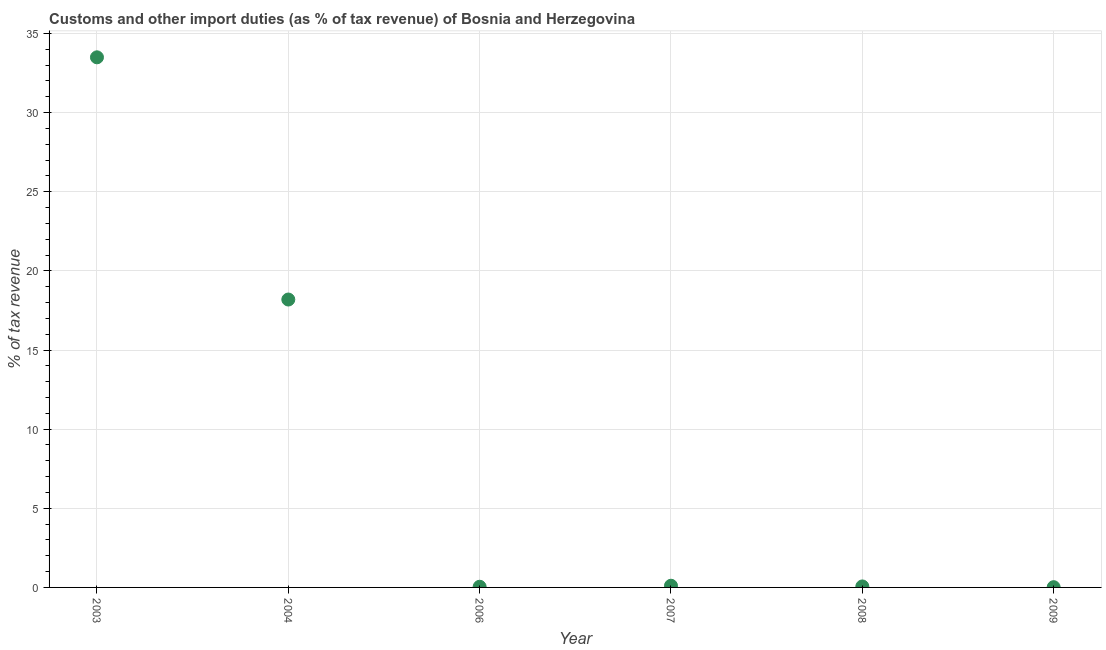What is the customs and other import duties in 2009?
Offer a very short reply. 0.02. Across all years, what is the maximum customs and other import duties?
Ensure brevity in your answer.  33.5. Across all years, what is the minimum customs and other import duties?
Offer a terse response. 0.02. In which year was the customs and other import duties maximum?
Ensure brevity in your answer.  2003. In which year was the customs and other import duties minimum?
Your answer should be very brief. 2009. What is the sum of the customs and other import duties?
Offer a terse response. 51.92. What is the difference between the customs and other import duties in 2003 and 2009?
Offer a very short reply. 33.48. What is the average customs and other import duties per year?
Offer a very short reply. 8.65. What is the median customs and other import duties?
Make the answer very short. 0.08. Do a majority of the years between 2006 and 2008 (inclusive) have customs and other import duties greater than 32 %?
Offer a terse response. No. What is the ratio of the customs and other import duties in 2003 to that in 2006?
Provide a succinct answer. 785.11. Is the customs and other import duties in 2004 less than that in 2006?
Your response must be concise. No. What is the difference between the highest and the second highest customs and other import duties?
Ensure brevity in your answer.  15.3. Is the sum of the customs and other import duties in 2008 and 2009 greater than the maximum customs and other import duties across all years?
Make the answer very short. No. What is the difference between the highest and the lowest customs and other import duties?
Offer a terse response. 33.48. Does the customs and other import duties monotonically increase over the years?
Your answer should be compact. No. How many dotlines are there?
Provide a short and direct response. 1. Are the values on the major ticks of Y-axis written in scientific E-notation?
Provide a short and direct response. No. What is the title of the graph?
Offer a very short reply. Customs and other import duties (as % of tax revenue) of Bosnia and Herzegovina. What is the label or title of the X-axis?
Give a very brief answer. Year. What is the label or title of the Y-axis?
Your answer should be compact. % of tax revenue. What is the % of tax revenue in 2003?
Your response must be concise. 33.5. What is the % of tax revenue in 2004?
Your response must be concise. 18.19. What is the % of tax revenue in 2006?
Make the answer very short. 0.04. What is the % of tax revenue in 2007?
Ensure brevity in your answer.  0.11. What is the % of tax revenue in 2008?
Your response must be concise. 0.06. What is the % of tax revenue in 2009?
Your answer should be very brief. 0.02. What is the difference between the % of tax revenue in 2003 and 2004?
Your response must be concise. 15.3. What is the difference between the % of tax revenue in 2003 and 2006?
Your response must be concise. 33.45. What is the difference between the % of tax revenue in 2003 and 2007?
Your answer should be very brief. 33.39. What is the difference between the % of tax revenue in 2003 and 2008?
Ensure brevity in your answer.  33.43. What is the difference between the % of tax revenue in 2003 and 2009?
Your answer should be very brief. 33.48. What is the difference between the % of tax revenue in 2004 and 2006?
Offer a very short reply. 18.15. What is the difference between the % of tax revenue in 2004 and 2007?
Provide a succinct answer. 18.09. What is the difference between the % of tax revenue in 2004 and 2008?
Offer a very short reply. 18.13. What is the difference between the % of tax revenue in 2004 and 2009?
Provide a succinct answer. 18.18. What is the difference between the % of tax revenue in 2006 and 2007?
Offer a very short reply. -0.06. What is the difference between the % of tax revenue in 2006 and 2008?
Your answer should be very brief. -0.02. What is the difference between the % of tax revenue in 2006 and 2009?
Your answer should be compact. 0.03. What is the difference between the % of tax revenue in 2007 and 2008?
Offer a very short reply. 0.04. What is the difference between the % of tax revenue in 2007 and 2009?
Ensure brevity in your answer.  0.09. What is the difference between the % of tax revenue in 2008 and 2009?
Your answer should be very brief. 0.05. What is the ratio of the % of tax revenue in 2003 to that in 2004?
Provide a succinct answer. 1.84. What is the ratio of the % of tax revenue in 2003 to that in 2006?
Your response must be concise. 785.11. What is the ratio of the % of tax revenue in 2003 to that in 2007?
Provide a short and direct response. 313.5. What is the ratio of the % of tax revenue in 2003 to that in 2008?
Give a very brief answer. 536.56. What is the ratio of the % of tax revenue in 2003 to that in 2009?
Offer a very short reply. 2165.8. What is the ratio of the % of tax revenue in 2004 to that in 2006?
Provide a succinct answer. 426.39. What is the ratio of the % of tax revenue in 2004 to that in 2007?
Provide a short and direct response. 170.26. What is the ratio of the % of tax revenue in 2004 to that in 2008?
Your response must be concise. 291.41. What is the ratio of the % of tax revenue in 2004 to that in 2009?
Your response must be concise. 1176.25. What is the ratio of the % of tax revenue in 2006 to that in 2007?
Ensure brevity in your answer.  0.4. What is the ratio of the % of tax revenue in 2006 to that in 2008?
Your answer should be very brief. 0.68. What is the ratio of the % of tax revenue in 2006 to that in 2009?
Provide a succinct answer. 2.76. What is the ratio of the % of tax revenue in 2007 to that in 2008?
Ensure brevity in your answer.  1.71. What is the ratio of the % of tax revenue in 2007 to that in 2009?
Your answer should be compact. 6.91. What is the ratio of the % of tax revenue in 2008 to that in 2009?
Offer a very short reply. 4.04. 